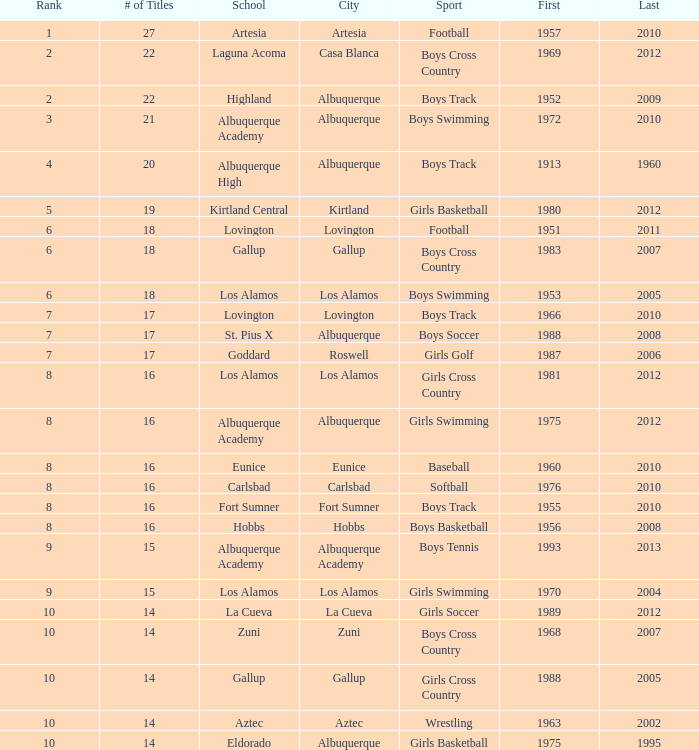Parse the table in full. {'header': ['Rank', '# of Titles', 'School', 'City', 'Sport', 'First', 'Last'], 'rows': [['1', '27', 'Artesia', 'Artesia', 'Football', '1957', '2010'], ['2', '22', 'Laguna Acoma', 'Casa Blanca', 'Boys Cross Country', '1969', '2012'], ['2', '22', 'Highland', 'Albuquerque', 'Boys Track', '1952', '2009'], ['3', '21', 'Albuquerque Academy', 'Albuquerque', 'Boys Swimming', '1972', '2010'], ['4', '20', 'Albuquerque High', 'Albuquerque', 'Boys Track', '1913', '1960'], ['5', '19', 'Kirtland Central', 'Kirtland', 'Girls Basketball', '1980', '2012'], ['6', '18', 'Lovington', 'Lovington', 'Football', '1951', '2011'], ['6', '18', 'Gallup', 'Gallup', 'Boys Cross Country', '1983', '2007'], ['6', '18', 'Los Alamos', 'Los Alamos', 'Boys Swimming', '1953', '2005'], ['7', '17', 'Lovington', 'Lovington', 'Boys Track', '1966', '2010'], ['7', '17', 'St. Pius X', 'Albuquerque', 'Boys Soccer', '1988', '2008'], ['7', '17', 'Goddard', 'Roswell', 'Girls Golf', '1987', '2006'], ['8', '16', 'Los Alamos', 'Los Alamos', 'Girls Cross Country', '1981', '2012'], ['8', '16', 'Albuquerque Academy', 'Albuquerque', 'Girls Swimming', '1975', '2012'], ['8', '16', 'Eunice', 'Eunice', 'Baseball', '1960', '2010'], ['8', '16', 'Carlsbad', 'Carlsbad', 'Softball', '1976', '2010'], ['8', '16', 'Fort Sumner', 'Fort Sumner', 'Boys Track', '1955', '2010'], ['8', '16', 'Hobbs', 'Hobbs', 'Boys Basketball', '1956', '2008'], ['9', '15', 'Albuquerque Academy', 'Albuquerque Academy', 'Boys Tennis', '1993', '2013'], ['9', '15', 'Los Alamos', 'Los Alamos', 'Girls Swimming', '1970', '2004'], ['10', '14', 'La Cueva', 'La Cueva', 'Girls Soccer', '1989', '2012'], ['10', '14', 'Zuni', 'Zuni', 'Boys Cross Country', '1968', '2007'], ['10', '14', 'Gallup', 'Gallup', 'Girls Cross Country', '1988', '2005'], ['10', '14', 'Aztec', 'Aztec', 'Wrestling', '1963', '2002'], ['10', '14', 'Eldorado', 'Albuquerque', 'Girls Basketball', '1975', '1995']]} In which city is the school that has fewer than 17 boys basketball titles, with the most recent one being after 2005? Hobbs. 